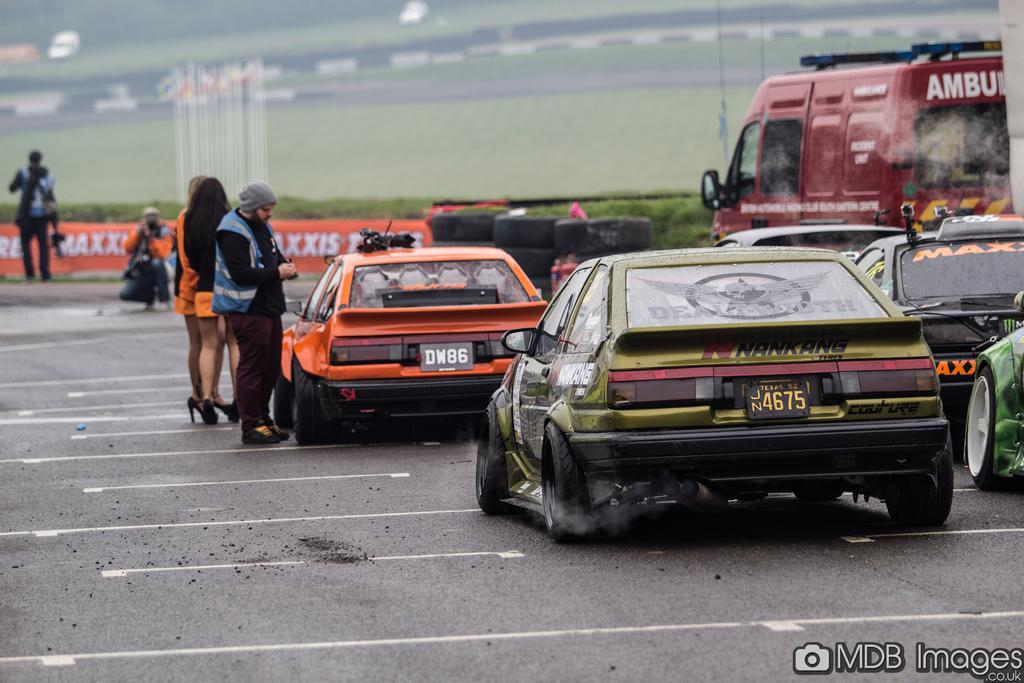How would you summarize this image in a sentence or two? This picture is clicked outside the city. In this picture, we see three people are standing on the road. Beside them, we see the vehicles are moving on the road. The man in the orange jacket is riding the bike. Behind him, we see a board or a banner in orange color with some text written on it. The man on the left side is standing. There are trees in the background. 